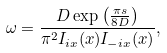Convert formula to latex. <formula><loc_0><loc_0><loc_500><loc_500>\omega = \frac { D \exp \left ( \frac { \pi s } { 8 D } \right ) } { \pi ^ { 2 } I _ { i x } ( x ) I _ { - i x } ( x ) } ,</formula> 